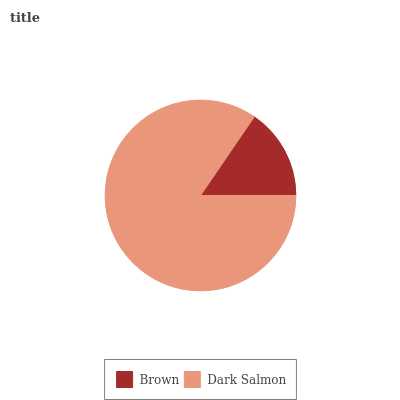Is Brown the minimum?
Answer yes or no. Yes. Is Dark Salmon the maximum?
Answer yes or no. Yes. Is Dark Salmon the minimum?
Answer yes or no. No. Is Dark Salmon greater than Brown?
Answer yes or no. Yes. Is Brown less than Dark Salmon?
Answer yes or no. Yes. Is Brown greater than Dark Salmon?
Answer yes or no. No. Is Dark Salmon less than Brown?
Answer yes or no. No. Is Dark Salmon the high median?
Answer yes or no. Yes. Is Brown the low median?
Answer yes or no. Yes. Is Brown the high median?
Answer yes or no. No. Is Dark Salmon the low median?
Answer yes or no. No. 